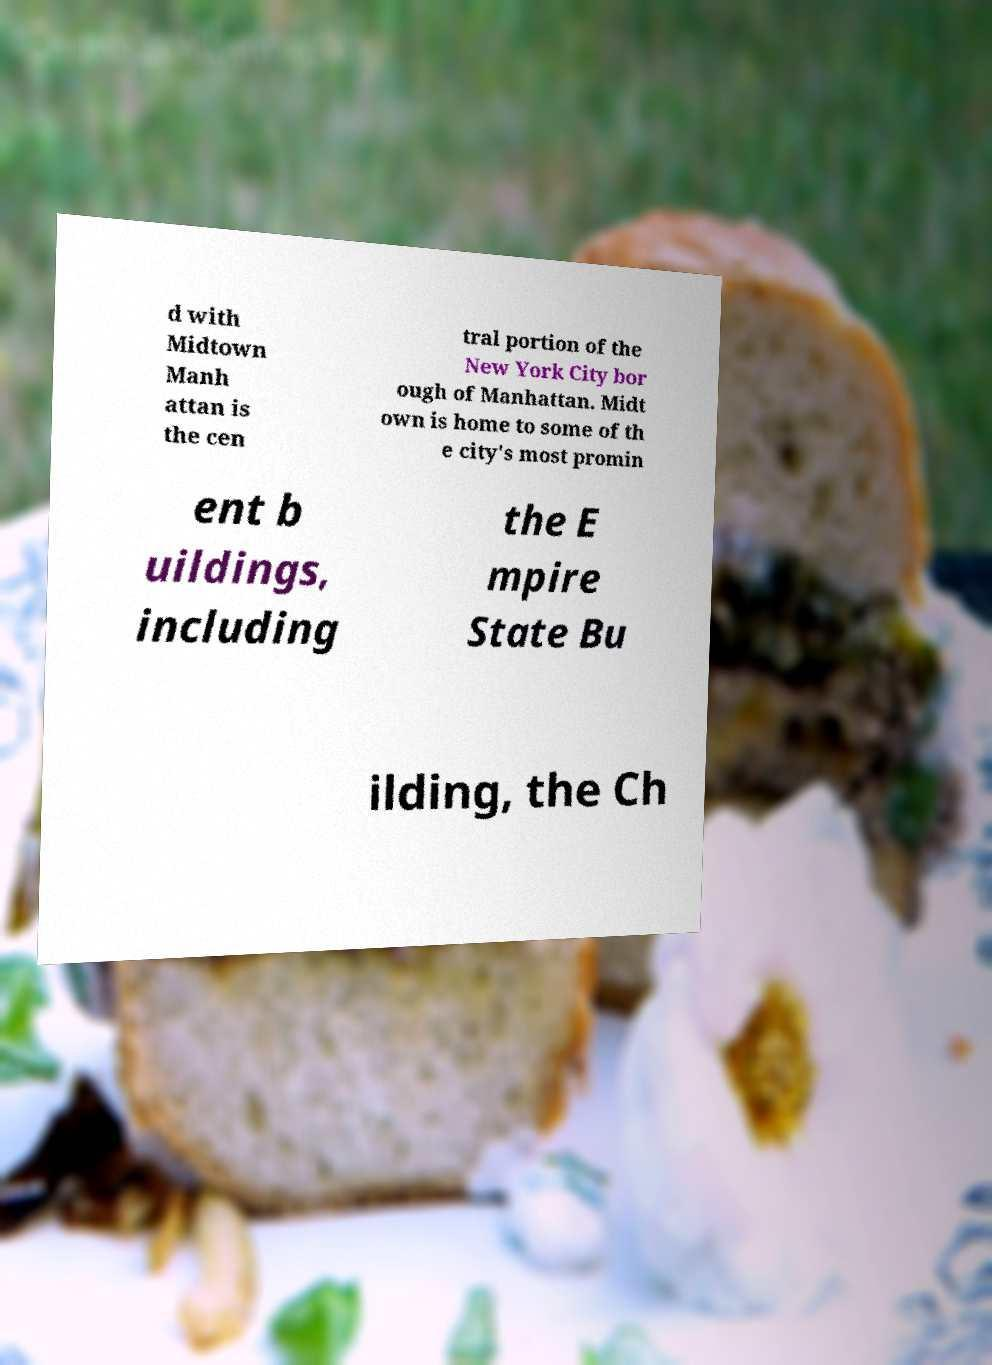Please identify and transcribe the text found in this image. d with Midtown Manh attan is the cen tral portion of the New York City bor ough of Manhattan. Midt own is home to some of th e city's most promin ent b uildings, including the E mpire State Bu ilding, the Ch 